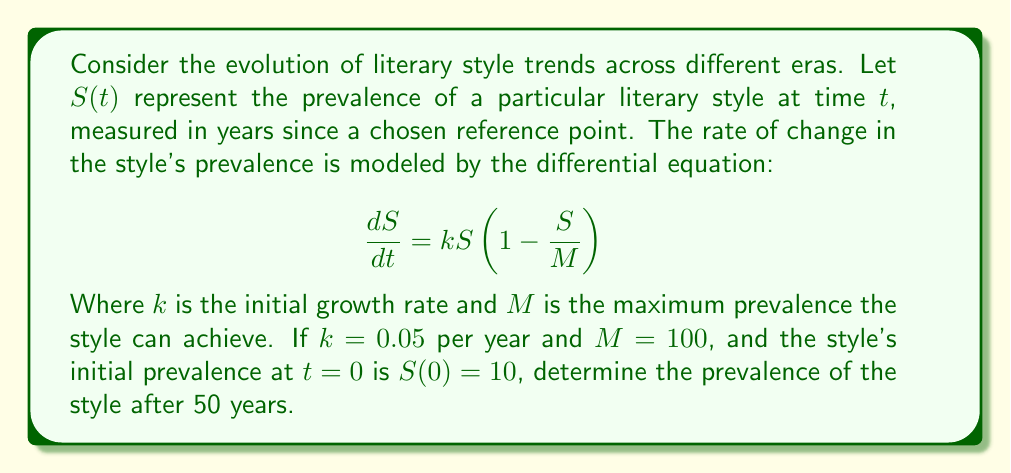Could you help me with this problem? To solve this problem, we need to recognize that this is a logistic growth model, often used to describe trends that have an initial period of exponential growth followed by a slowdown as the trend approaches its maximum potential.

1. The given differential equation is in the form of the logistic equation:

   $$\frac{dS}{dt} = kS(1-\frac{S}{M})$$

2. The solution to this equation is:

   $$S(t) = \frac{M}{1 + (\frac{M}{S_0} - 1)e^{-kt}}$$

   Where $S_0$ is the initial value of $S$ at $t=0$.

3. We are given:
   - $k = 0.05$ per year
   - $M = 100$
   - $S_0 = S(0) = 10$
   - We need to find $S(50)$

4. Substituting these values into the solution:

   $$S(50) = \frac{100}{1 + (\frac{100}{10} - 1)e^{-0.05(50)}}$$

5. Simplifying:
   
   $$S(50) = \frac{100}{1 + 9e^{-2.5}}$$

6. Calculating:
   
   $$S(50) \approx 78.43$$

This result indicates that after 50 years, the prevalence of the literary style will have reached about 78.43% of its maximum potential.
Answer: $S(50) \approx 78.43$ 